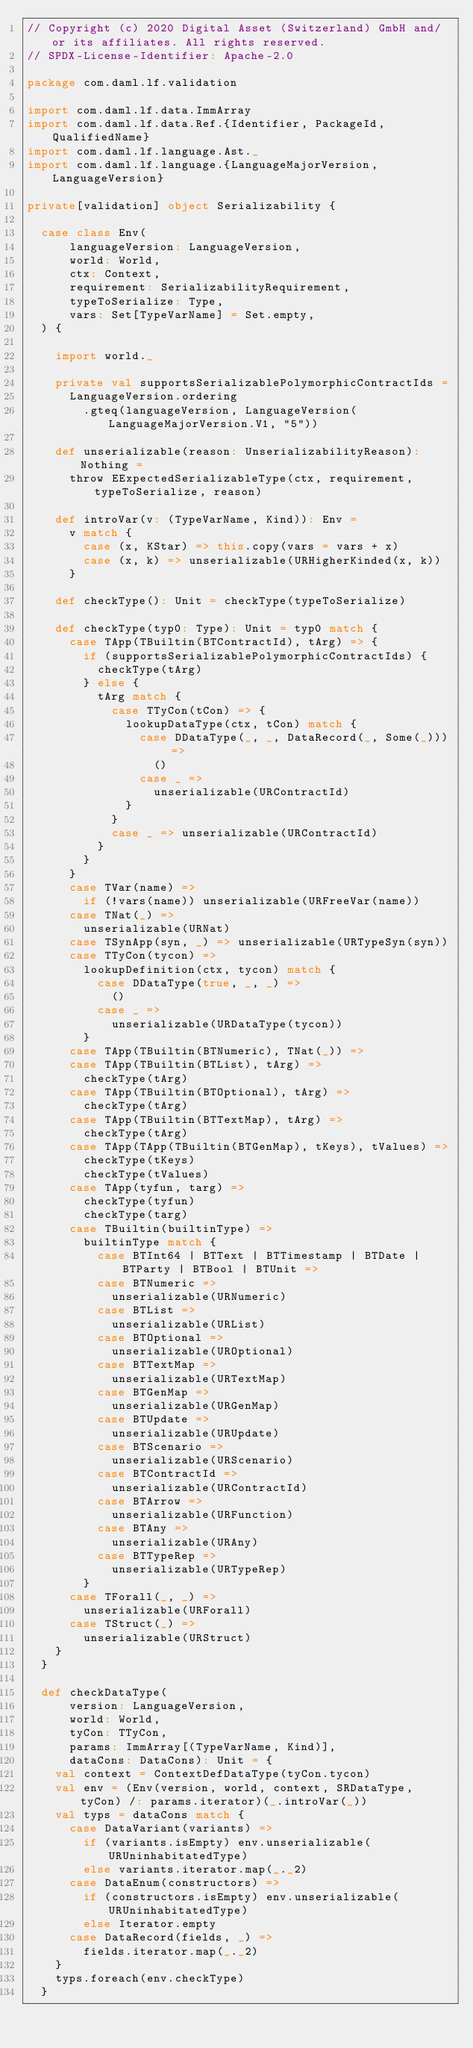<code> <loc_0><loc_0><loc_500><loc_500><_Scala_>// Copyright (c) 2020 Digital Asset (Switzerland) GmbH and/or its affiliates. All rights reserved.
// SPDX-License-Identifier: Apache-2.0

package com.daml.lf.validation

import com.daml.lf.data.ImmArray
import com.daml.lf.data.Ref.{Identifier, PackageId, QualifiedName}
import com.daml.lf.language.Ast._
import com.daml.lf.language.{LanguageMajorVersion, LanguageVersion}

private[validation] object Serializability {

  case class Env(
      languageVersion: LanguageVersion,
      world: World,
      ctx: Context,
      requirement: SerializabilityRequirement,
      typeToSerialize: Type,
      vars: Set[TypeVarName] = Set.empty,
  ) {

    import world._

    private val supportsSerializablePolymorphicContractIds =
      LanguageVersion.ordering
        .gteq(languageVersion, LanguageVersion(LanguageMajorVersion.V1, "5"))

    def unserializable(reason: UnserializabilityReason): Nothing =
      throw EExpectedSerializableType(ctx, requirement, typeToSerialize, reason)

    def introVar(v: (TypeVarName, Kind)): Env =
      v match {
        case (x, KStar) => this.copy(vars = vars + x)
        case (x, k) => unserializable(URHigherKinded(x, k))
      }

    def checkType(): Unit = checkType(typeToSerialize)

    def checkType(typ0: Type): Unit = typ0 match {
      case TApp(TBuiltin(BTContractId), tArg) => {
        if (supportsSerializablePolymorphicContractIds) {
          checkType(tArg)
        } else {
          tArg match {
            case TTyCon(tCon) => {
              lookupDataType(ctx, tCon) match {
                case DDataType(_, _, DataRecord(_, Some(_))) =>
                  ()
                case _ =>
                  unserializable(URContractId)
              }
            }
            case _ => unserializable(URContractId)
          }
        }
      }
      case TVar(name) =>
        if (!vars(name)) unserializable(URFreeVar(name))
      case TNat(_) =>
        unserializable(URNat)
      case TSynApp(syn, _) => unserializable(URTypeSyn(syn))
      case TTyCon(tycon) =>
        lookupDefinition(ctx, tycon) match {
          case DDataType(true, _, _) =>
            ()
          case _ =>
            unserializable(URDataType(tycon))
        }
      case TApp(TBuiltin(BTNumeric), TNat(_)) =>
      case TApp(TBuiltin(BTList), tArg) =>
        checkType(tArg)
      case TApp(TBuiltin(BTOptional), tArg) =>
        checkType(tArg)
      case TApp(TBuiltin(BTTextMap), tArg) =>
        checkType(tArg)
      case TApp(TApp(TBuiltin(BTGenMap), tKeys), tValues) =>
        checkType(tKeys)
        checkType(tValues)
      case TApp(tyfun, targ) =>
        checkType(tyfun)
        checkType(targ)
      case TBuiltin(builtinType) =>
        builtinType match {
          case BTInt64 | BTText | BTTimestamp | BTDate | BTParty | BTBool | BTUnit =>
          case BTNumeric =>
            unserializable(URNumeric)
          case BTList =>
            unserializable(URList)
          case BTOptional =>
            unserializable(UROptional)
          case BTTextMap =>
            unserializable(URTextMap)
          case BTGenMap =>
            unserializable(URGenMap)
          case BTUpdate =>
            unserializable(URUpdate)
          case BTScenario =>
            unserializable(URScenario)
          case BTContractId =>
            unserializable(URContractId)
          case BTArrow =>
            unserializable(URFunction)
          case BTAny =>
            unserializable(URAny)
          case BTTypeRep =>
            unserializable(URTypeRep)
        }
      case TForall(_, _) =>
        unserializable(URForall)
      case TStruct(_) =>
        unserializable(URStruct)
    }
  }

  def checkDataType(
      version: LanguageVersion,
      world: World,
      tyCon: TTyCon,
      params: ImmArray[(TypeVarName, Kind)],
      dataCons: DataCons): Unit = {
    val context = ContextDefDataType(tyCon.tycon)
    val env = (Env(version, world, context, SRDataType, tyCon) /: params.iterator)(_.introVar(_))
    val typs = dataCons match {
      case DataVariant(variants) =>
        if (variants.isEmpty) env.unserializable(URUninhabitatedType)
        else variants.iterator.map(_._2)
      case DataEnum(constructors) =>
        if (constructors.isEmpty) env.unserializable(URUninhabitatedType)
        else Iterator.empty
      case DataRecord(fields, _) =>
        fields.iterator.map(_._2)
    }
    typs.foreach(env.checkType)
  }
</code> 